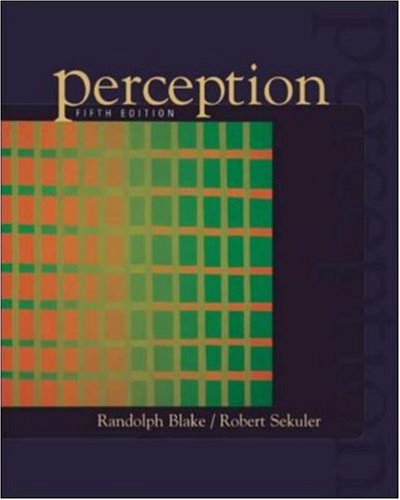Can you describe a key experiment or study illustrated in this book? One of the key studies illustrated in the book examines the phenomenon of binocular rivalry, where two different images presented to each eye lead to a switching perception. 